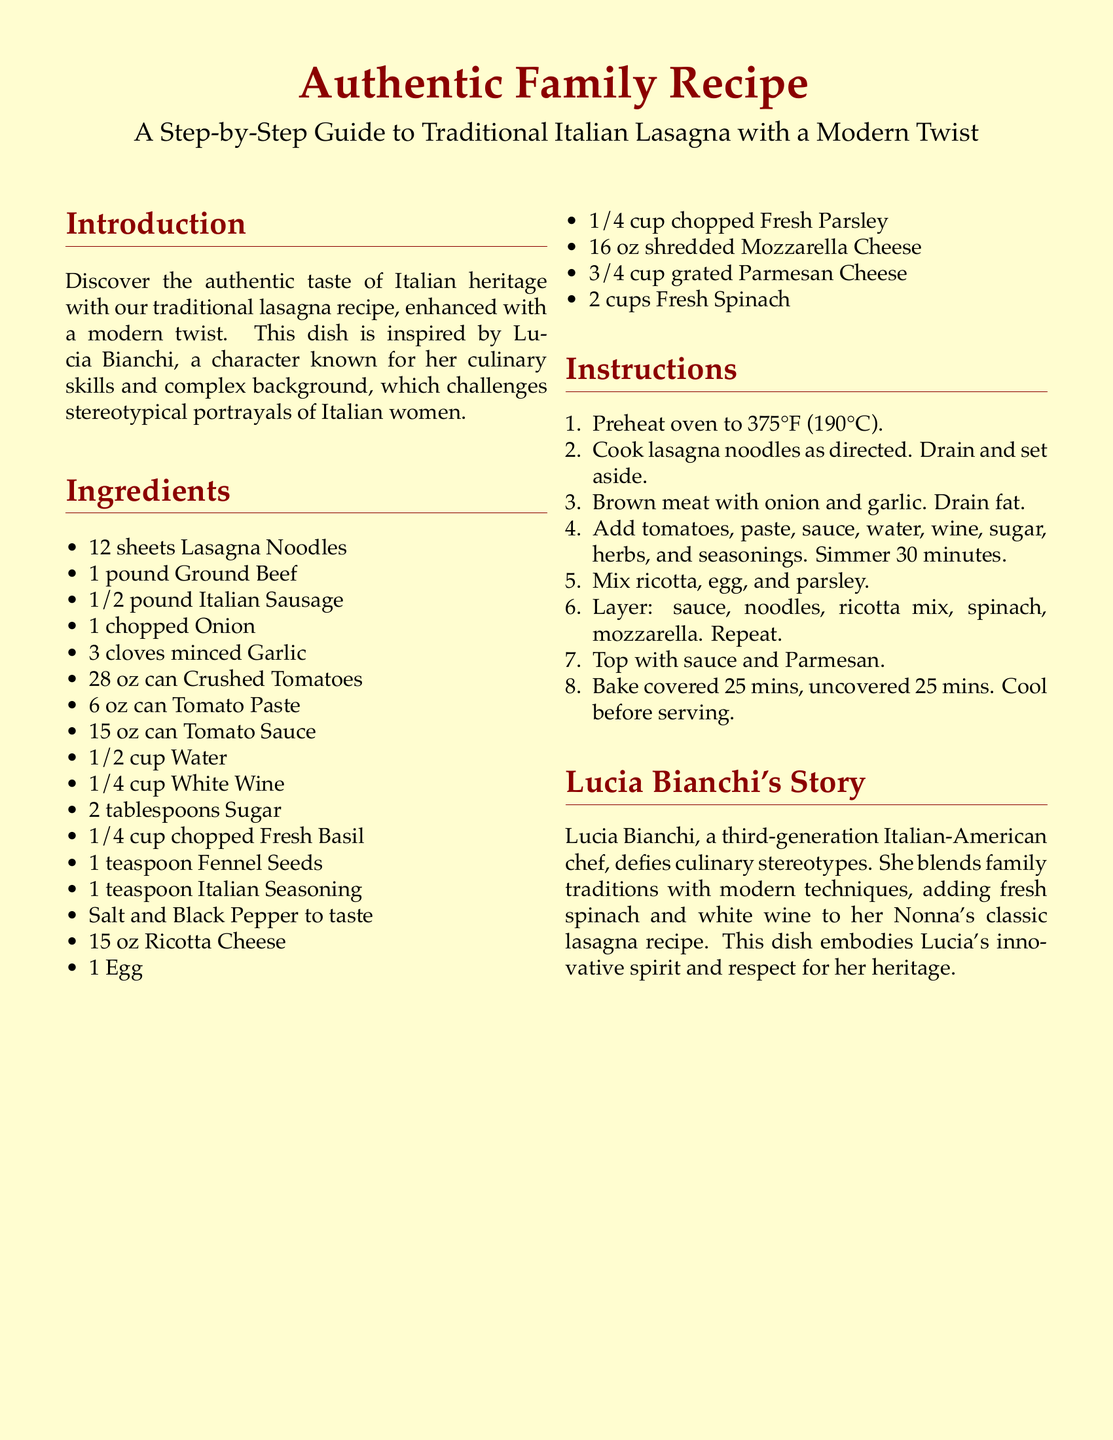what is the main dish featured in the recipe? The document highlights a specific traditional dish, which is a layered pasta dish typical to Italian cuisine.
Answer: Lasagna who is the character that inspired the recipe? The character is mentioned as an influential figure in the text, showcasing her background and culinary skills.
Answer: Lucia Bianchi how many sheets of lasagna noodles are needed? The document lists the ingredients required to prepare the dish and specifies the quantity for the noodles.
Answer: 12 sheets what ingredient adds flavor and moisture from the wine? The recipe includes a specific alcoholic ingredient that enhances the sauce by adding complexity to the flavor.
Answer: White Wine what is the baking temperature for the lasagna? The document specifies a precise temperature for baking the lasagna to ensure proper cooking.
Answer: 375°F (190°C) how many cups of fresh spinach are included in the recipe? The ingredients list provides a specific quantity required for this vegetable within the lasagna.
Answer: 2 cups what is one modern twist Lucia incorporates into her lasagna? The text describes a particular addition to the traditional recipe that reflects a contemporary approach to the dish.
Answer: Fresh Spinach how long should the lasagna bake uncovered? The instructions detail the baking time required after covering the dish with foil, specifying when to remove it.
Answer: 25 minutes what type of cheese is used alongside ricotta in the layers? The recipe indicates a type of cheese that is commonly used in lasagna, contributing to its richness and texture.
Answer: Mozzarella Cheese 